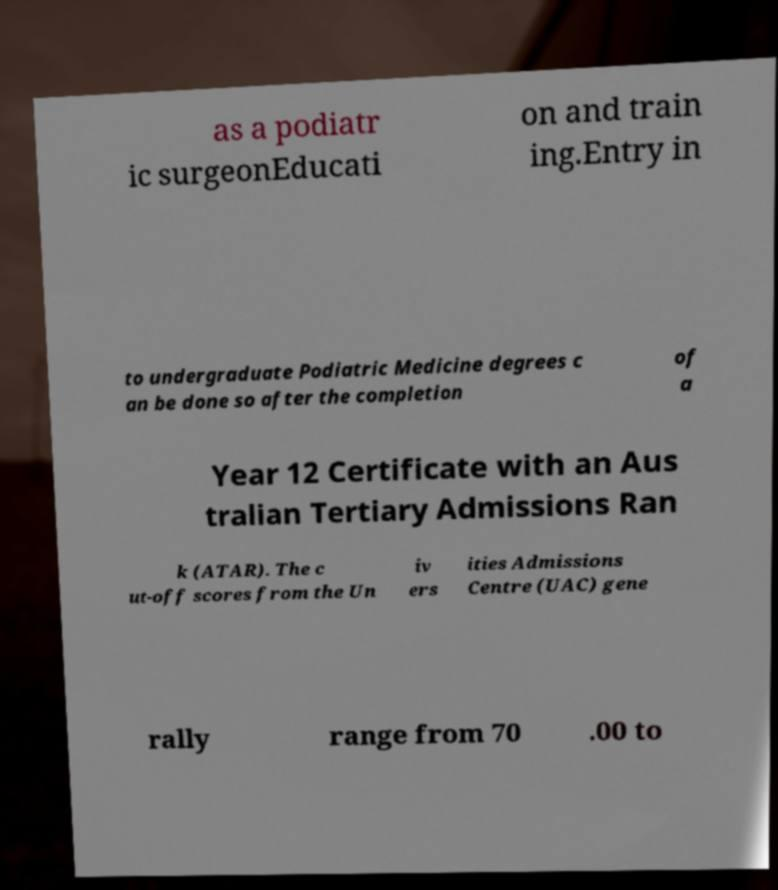Could you assist in decoding the text presented in this image and type it out clearly? as a podiatr ic surgeonEducati on and train ing.Entry in to undergraduate Podiatric Medicine degrees c an be done so after the completion of a Year 12 Certificate with an Aus tralian Tertiary Admissions Ran k (ATAR). The c ut-off scores from the Un iv ers ities Admissions Centre (UAC) gene rally range from 70 .00 to 